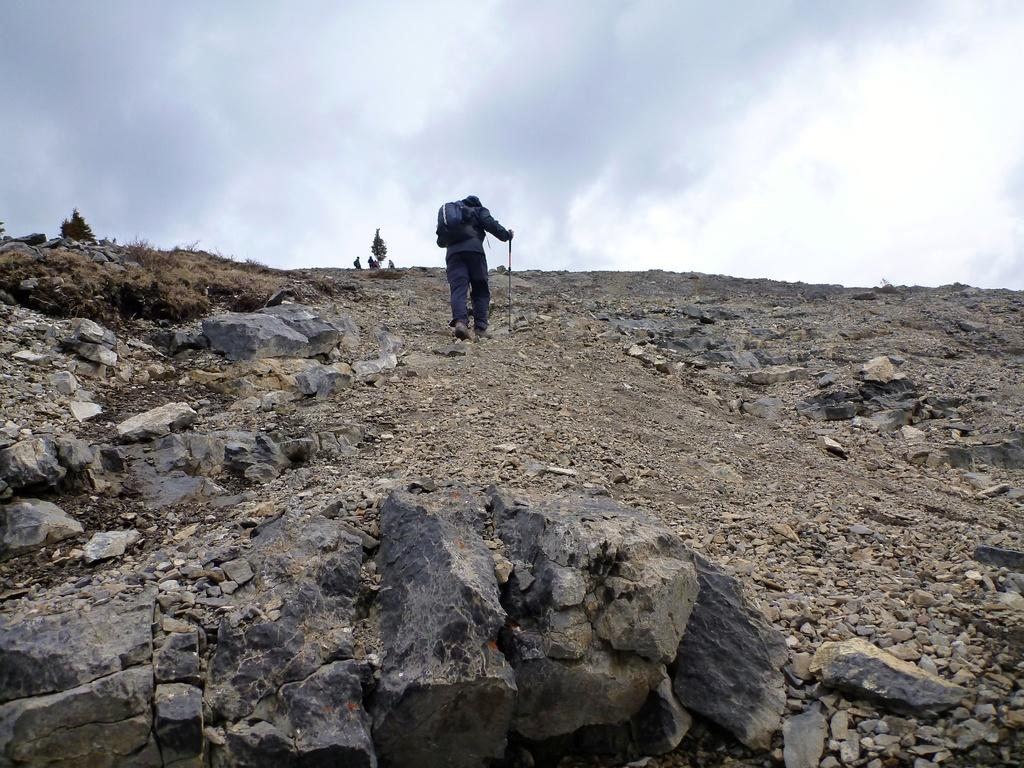What is the person in the image doing? The person in the image is walking. What is the person holding while walking? The person is holding a stick. What else is the person carrying? The person is carrying a bag. What type of terrain can be seen in the image? There are rocks, trees, and grass visible in the image. What is visible in the background of the image? The sky is visible in the background of the image. Can you see a rabbit hopping on a hill in the image? There is no hill or rabbit present in the image. 